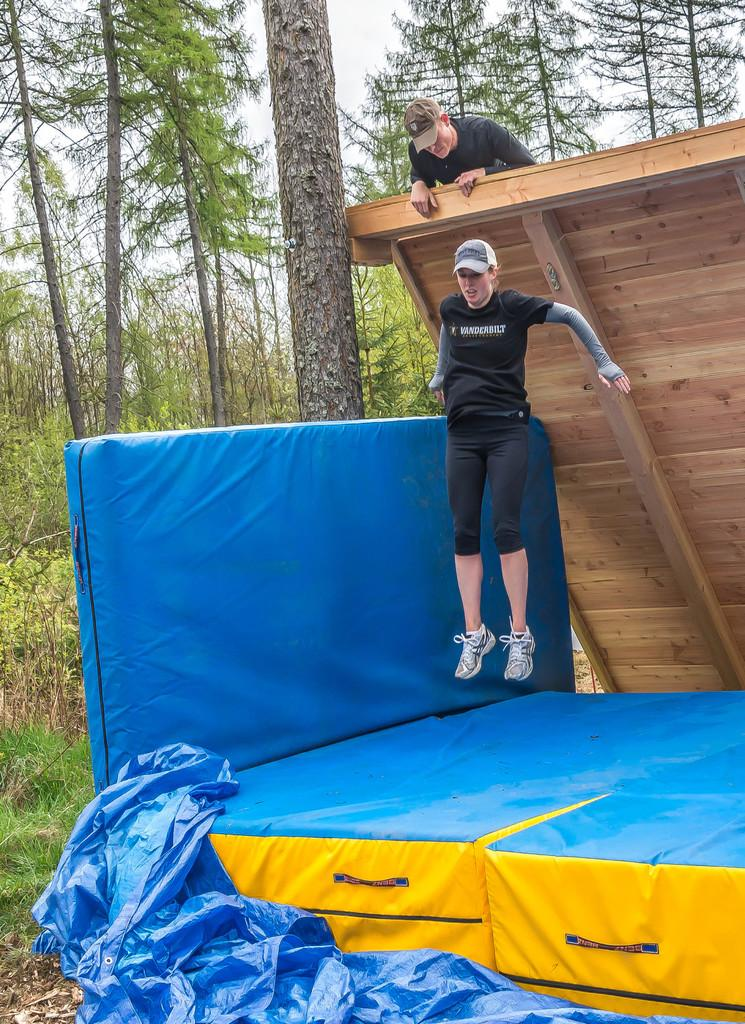How many people are in the image? There are two persons in the image. What color is the bed in the image? The bed in the image is blue. What is at the bottom of the image? There is a blue color cover at the bottom of the image. What can be seen in the background of the image? There are trees in the background of the image. What type of poison is being used to create humor in the image? There is no poison or humor present in the image; it features two people and a blue color bed with a blue color cover in front of trees. 